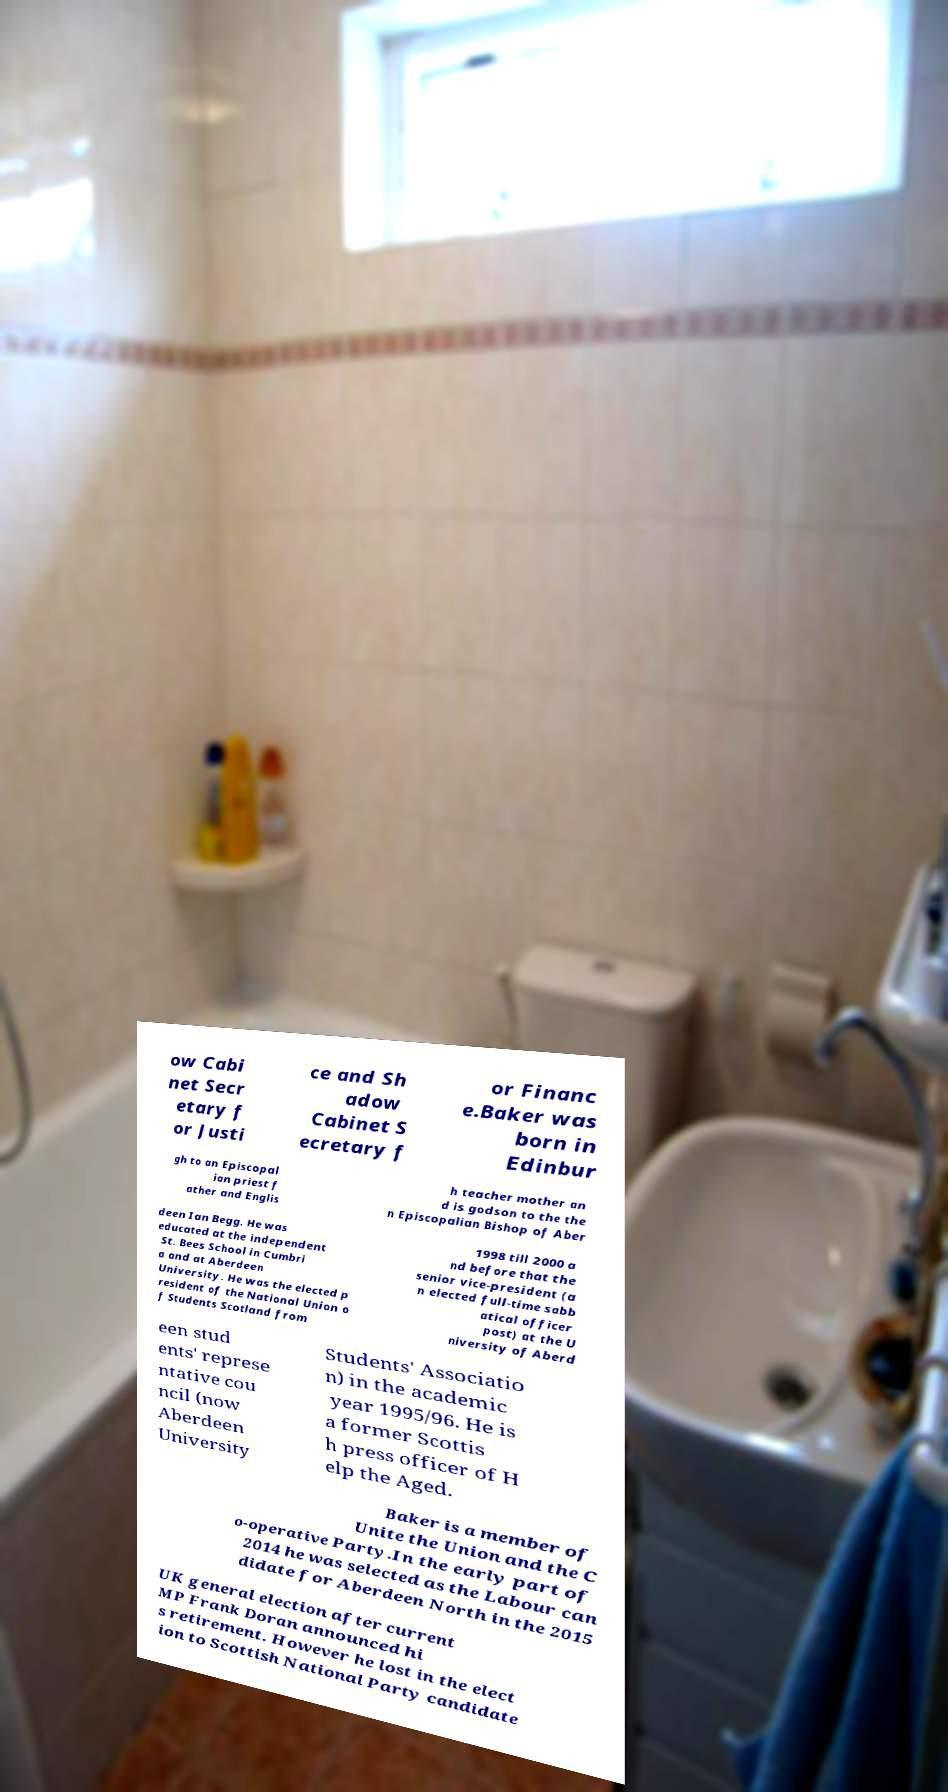What messages or text are displayed in this image? I need them in a readable, typed format. ow Cabi net Secr etary f or Justi ce and Sh adow Cabinet S ecretary f or Financ e.Baker was born in Edinbur gh to an Episcopal ian priest f ather and Englis h teacher mother an d is godson to the the n Episcopalian Bishop of Aber deen Ian Begg. He was educated at the independent St. Bees School in Cumbri a and at Aberdeen University. He was the elected p resident of the National Union o f Students Scotland from 1998 till 2000 a nd before that the senior vice-president (a n elected full-time sabb atical officer post) at the U niversity of Aberd een stud ents' represe ntative cou ncil (now Aberdeen University Students' Associatio n) in the academic year 1995/96. He is a former Scottis h press officer of H elp the Aged. Baker is a member of Unite the Union and the C o-operative Party.In the early part of 2014 he was selected as the Labour can didate for Aberdeen North in the 2015 UK general election after current MP Frank Doran announced hi s retirement. However he lost in the elect ion to Scottish National Party candidate 